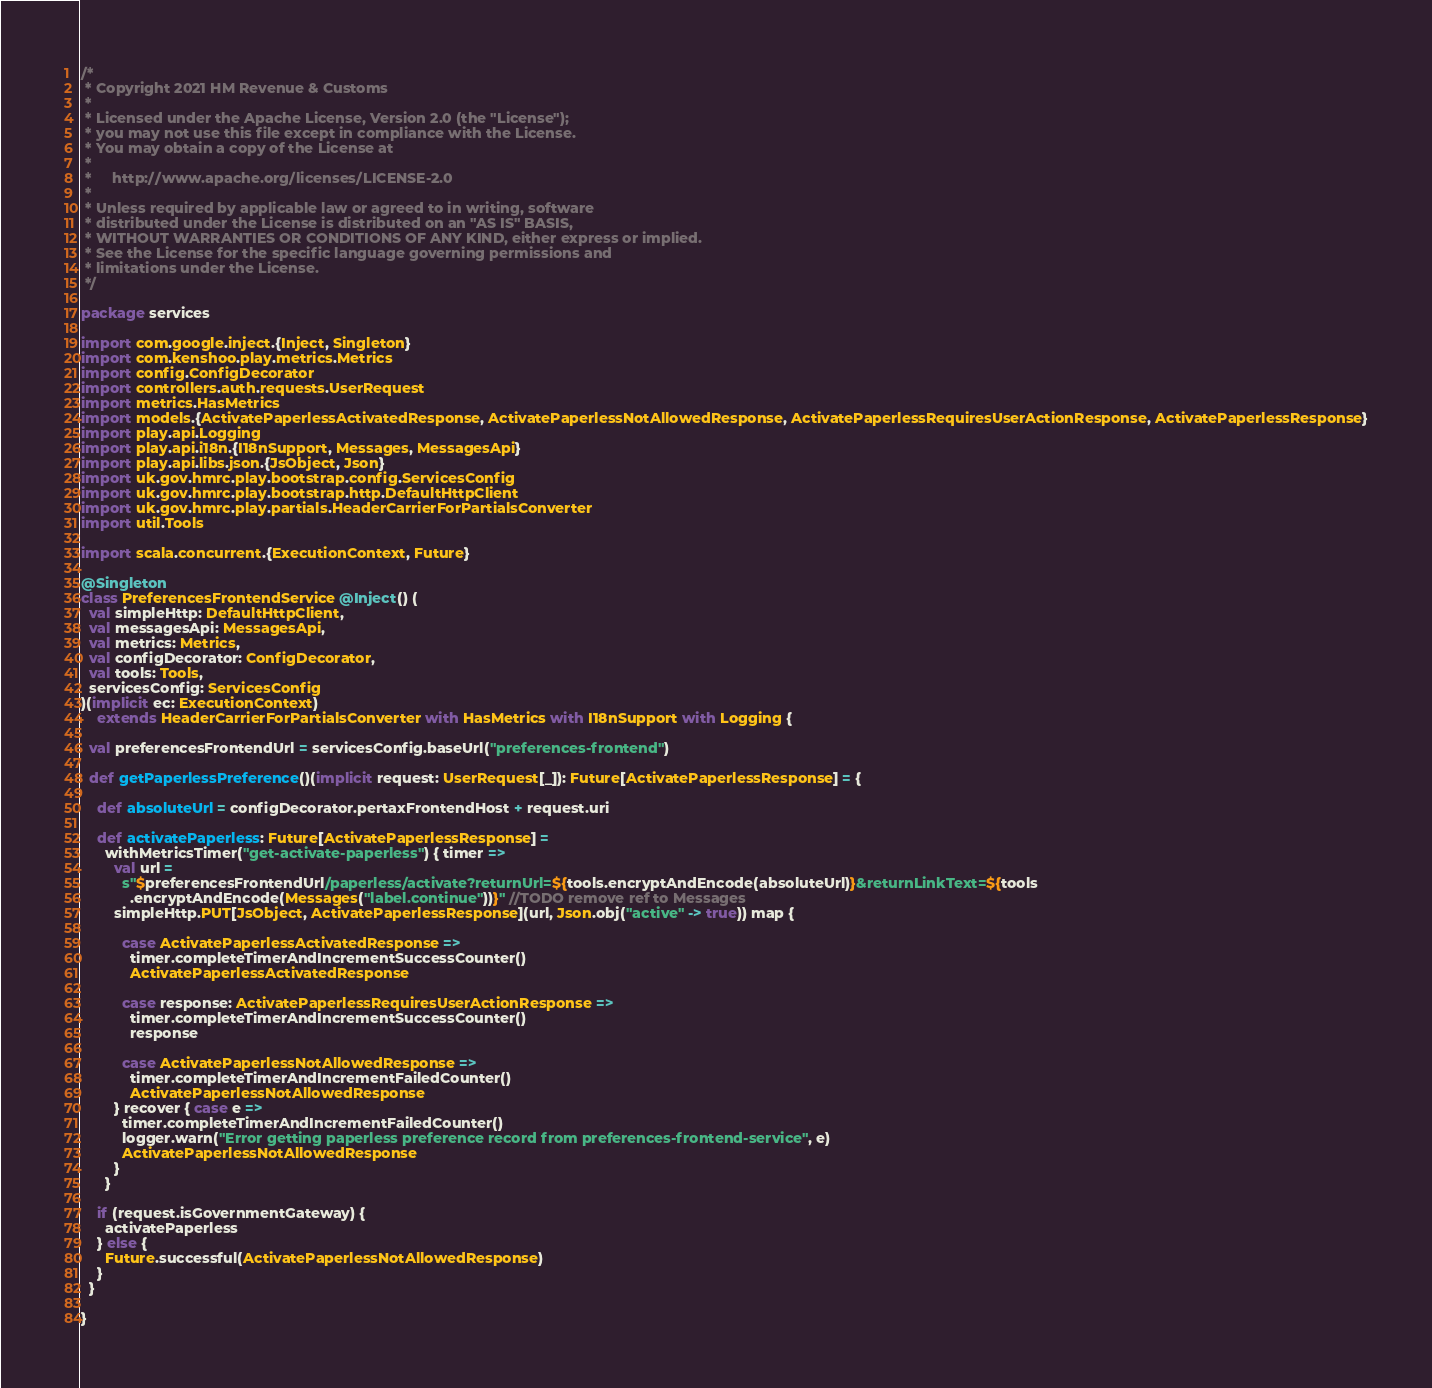<code> <loc_0><loc_0><loc_500><loc_500><_Scala_>/*
 * Copyright 2021 HM Revenue & Customs
 *
 * Licensed under the Apache License, Version 2.0 (the "License");
 * you may not use this file except in compliance with the License.
 * You may obtain a copy of the License at
 *
 *     http://www.apache.org/licenses/LICENSE-2.0
 *
 * Unless required by applicable law or agreed to in writing, software
 * distributed under the License is distributed on an "AS IS" BASIS,
 * WITHOUT WARRANTIES OR CONDITIONS OF ANY KIND, either express or implied.
 * See the License for the specific language governing permissions and
 * limitations under the License.
 */

package services

import com.google.inject.{Inject, Singleton}
import com.kenshoo.play.metrics.Metrics
import config.ConfigDecorator
import controllers.auth.requests.UserRequest
import metrics.HasMetrics
import models.{ActivatePaperlessActivatedResponse, ActivatePaperlessNotAllowedResponse, ActivatePaperlessRequiresUserActionResponse, ActivatePaperlessResponse}
import play.api.Logging
import play.api.i18n.{I18nSupport, Messages, MessagesApi}
import play.api.libs.json.{JsObject, Json}
import uk.gov.hmrc.play.bootstrap.config.ServicesConfig
import uk.gov.hmrc.play.bootstrap.http.DefaultHttpClient
import uk.gov.hmrc.play.partials.HeaderCarrierForPartialsConverter
import util.Tools

import scala.concurrent.{ExecutionContext, Future}

@Singleton
class PreferencesFrontendService @Inject() (
  val simpleHttp: DefaultHttpClient,
  val messagesApi: MessagesApi,
  val metrics: Metrics,
  val configDecorator: ConfigDecorator,
  val tools: Tools,
  servicesConfig: ServicesConfig
)(implicit ec: ExecutionContext)
    extends HeaderCarrierForPartialsConverter with HasMetrics with I18nSupport with Logging {

  val preferencesFrontendUrl = servicesConfig.baseUrl("preferences-frontend")

  def getPaperlessPreference()(implicit request: UserRequest[_]): Future[ActivatePaperlessResponse] = {

    def absoluteUrl = configDecorator.pertaxFrontendHost + request.uri

    def activatePaperless: Future[ActivatePaperlessResponse] =
      withMetricsTimer("get-activate-paperless") { timer =>
        val url =
          s"$preferencesFrontendUrl/paperless/activate?returnUrl=${tools.encryptAndEncode(absoluteUrl)}&returnLinkText=${tools
            .encryptAndEncode(Messages("label.continue"))}" //TODO remove ref to Messages
        simpleHttp.PUT[JsObject, ActivatePaperlessResponse](url, Json.obj("active" -> true)) map {

          case ActivatePaperlessActivatedResponse =>
            timer.completeTimerAndIncrementSuccessCounter()
            ActivatePaperlessActivatedResponse

          case response: ActivatePaperlessRequiresUserActionResponse =>
            timer.completeTimerAndIncrementSuccessCounter()
            response

          case ActivatePaperlessNotAllowedResponse =>
            timer.completeTimerAndIncrementFailedCounter()
            ActivatePaperlessNotAllowedResponse
        } recover { case e =>
          timer.completeTimerAndIncrementFailedCounter()
          logger.warn("Error getting paperless preference record from preferences-frontend-service", e)
          ActivatePaperlessNotAllowedResponse
        }
      }

    if (request.isGovernmentGateway) {
      activatePaperless
    } else {
      Future.successful(ActivatePaperlessNotAllowedResponse)
    }
  }

}
</code> 